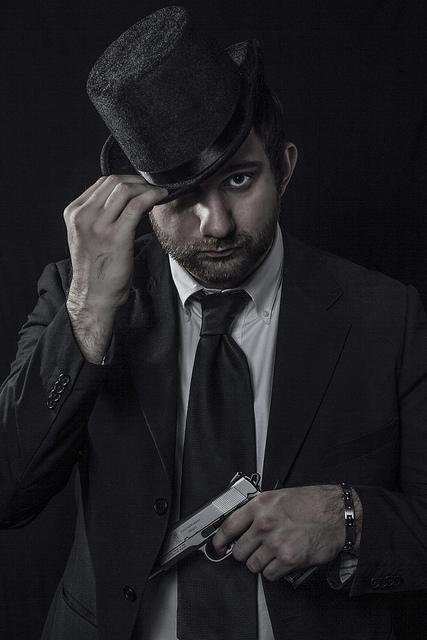Is this man worried about his image?
Give a very brief answer. Yes. What color is the man's tie?
Write a very short answer. Black. What is he holding in his right hand?
Write a very short answer. Hat. How many ties are shown?
Give a very brief answer. 1. Is there a gun?
Quick response, please. Yes. Is the man a tour guide?
Give a very brief answer. No. What is he doing?
Answer briefly. Tipping hat. What color is the hat on the man in the reflection?
Be succinct. Black. What is the man holding?
Quick response, please. Gun. Is this a bad guy?
Give a very brief answer. Yes. Is this a real weapon?
Answer briefly. Yes. Is this man communicating with an enemy?
Short answer required. Yes. What is on the man's arm?
Concise answer only. Watch. What is he wearing on his head?
Concise answer only. Hat. Is there a design on the tie?
Keep it brief. No. Is this man talking?
Short answer required. No. 